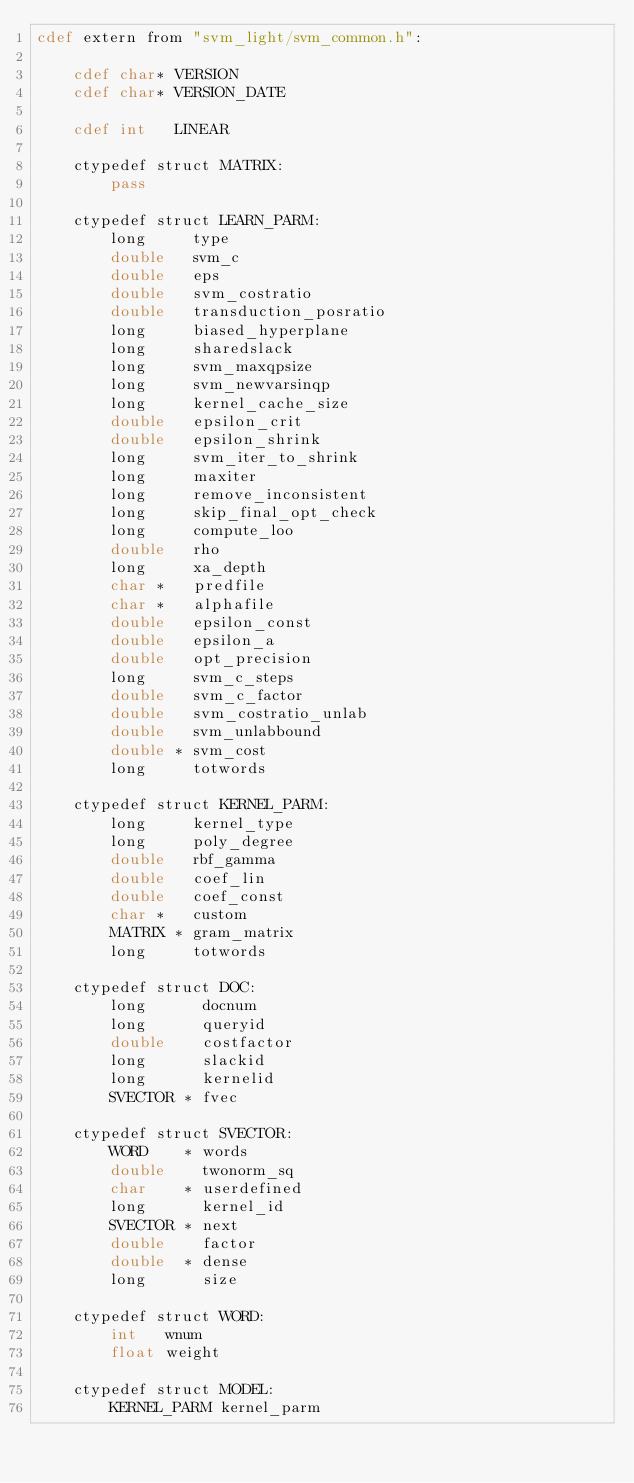<code> <loc_0><loc_0><loc_500><loc_500><_Cython_>cdef extern from "svm_light/svm_common.h":

    cdef char* VERSION
    cdef char* VERSION_DATE

    cdef int   LINEAR

    ctypedef struct MATRIX:
        pass

    ctypedef struct LEARN_PARM:
        long     type
        double   svm_c
        double   eps
        double   svm_costratio
        double   transduction_posratio
        long     biased_hyperplane
        long     sharedslack
        long     svm_maxqpsize
        long     svm_newvarsinqp
        long     kernel_cache_size
        double   epsilon_crit
        double   epsilon_shrink
        long     svm_iter_to_shrink
        long     maxiter
        long     remove_inconsistent
        long     skip_final_opt_check
        long     compute_loo
        double   rho
        long     xa_depth
        char *   predfile
        char *   alphafile
        double   epsilon_const
        double   epsilon_a
        double   opt_precision
        long     svm_c_steps
        double   svm_c_factor
        double   svm_costratio_unlab
        double   svm_unlabbound
        double * svm_cost
        long     totwords

    ctypedef struct KERNEL_PARM:
        long     kernel_type
        long     poly_degree
        double   rbf_gamma
        double   coef_lin
        double   coef_const
        char *   custom
        MATRIX * gram_matrix
        long     totwords

    ctypedef struct DOC:
        long      docnum
        long      queryid
        double    costfactor
        long      slackid
        long      kernelid
        SVECTOR * fvec

    ctypedef struct SVECTOR:
        WORD    * words
        double    twonorm_sq
        char    * userdefined
        long      kernel_id
        SVECTOR * next
        double    factor
        double  * dense
        long      size

    ctypedef struct WORD:
        int   wnum
        float weight

    ctypedef struct MODEL:
        KERNEL_PARM kernel_parm</code> 